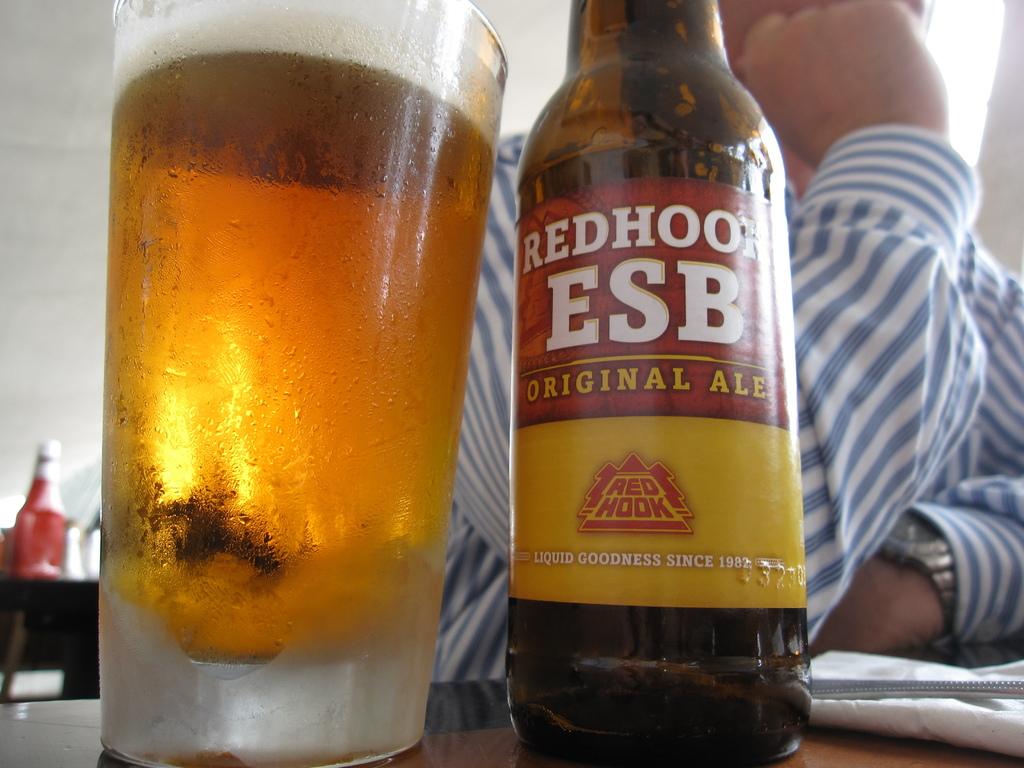What type of drink is it?
Provide a succinct answer. Ale. 